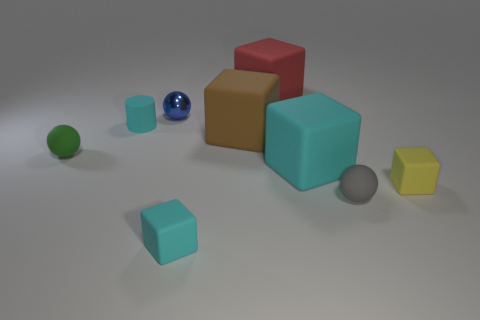Is the shape of the blue metallic thing the same as the tiny cyan thing that is on the right side of the blue metallic sphere?
Provide a succinct answer. No. What material is the tiny blue sphere?
Ensure brevity in your answer.  Metal. What is the size of the red matte object that is the same shape as the yellow object?
Your answer should be compact. Large. What number of other objects are there of the same material as the tiny gray sphere?
Provide a short and direct response. 7. Does the big red block have the same material as the cyan cube that is right of the red object?
Your response must be concise. Yes. Is the number of rubber balls to the right of the gray rubber ball less than the number of blue metallic balls left of the green matte sphere?
Ensure brevity in your answer.  No. What color is the small rubber block on the right side of the gray matte thing?
Keep it short and to the point. Yellow. What number of other things are there of the same color as the tiny rubber cylinder?
Offer a terse response. 2. There is a cyan object on the left side of the blue shiny object; is it the same size as the small yellow rubber thing?
Your response must be concise. Yes. How many matte objects are left of the yellow thing?
Offer a terse response. 7. 